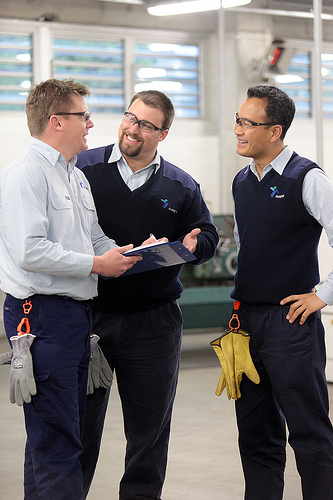<image>
Is there a man on the man? No. The man is not positioned on the man. They may be near each other, but the man is not supported by or resting on top of the man. 